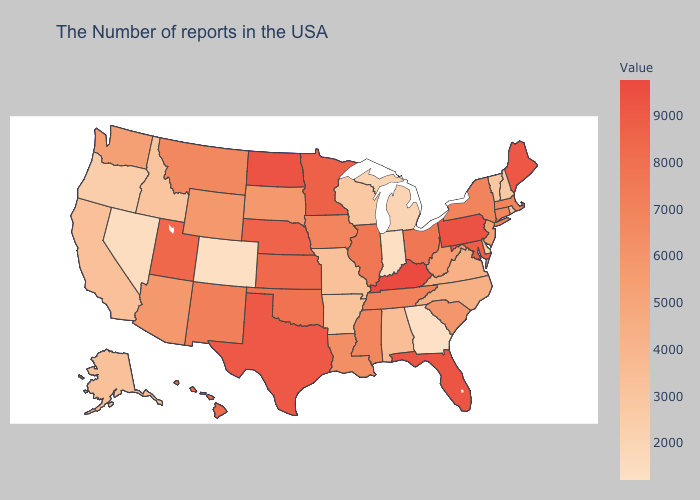Which states have the highest value in the USA?
Give a very brief answer. Kentucky. Which states have the highest value in the USA?
Write a very short answer. Kentucky. Which states have the lowest value in the West?
Short answer required. Colorado. Is the legend a continuous bar?
Quick response, please. Yes. Does New Jersey have a lower value than Montana?
Give a very brief answer. Yes. 